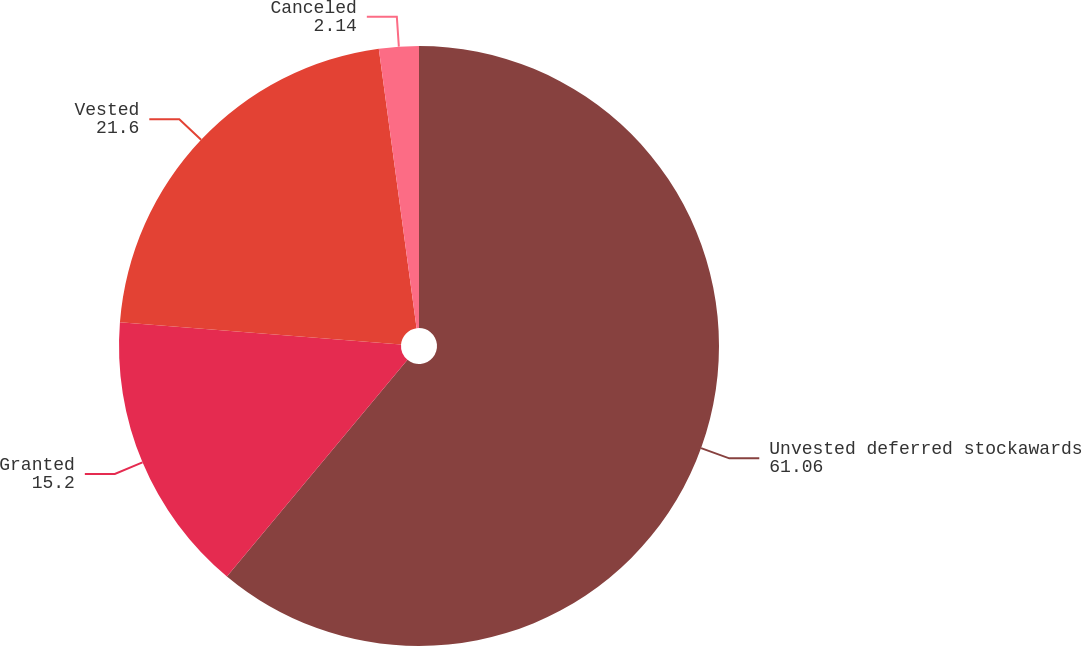Convert chart. <chart><loc_0><loc_0><loc_500><loc_500><pie_chart><fcel>Unvested deferred stockawards<fcel>Granted<fcel>Vested<fcel>Canceled<nl><fcel>61.06%<fcel>15.2%<fcel>21.6%<fcel>2.14%<nl></chart> 